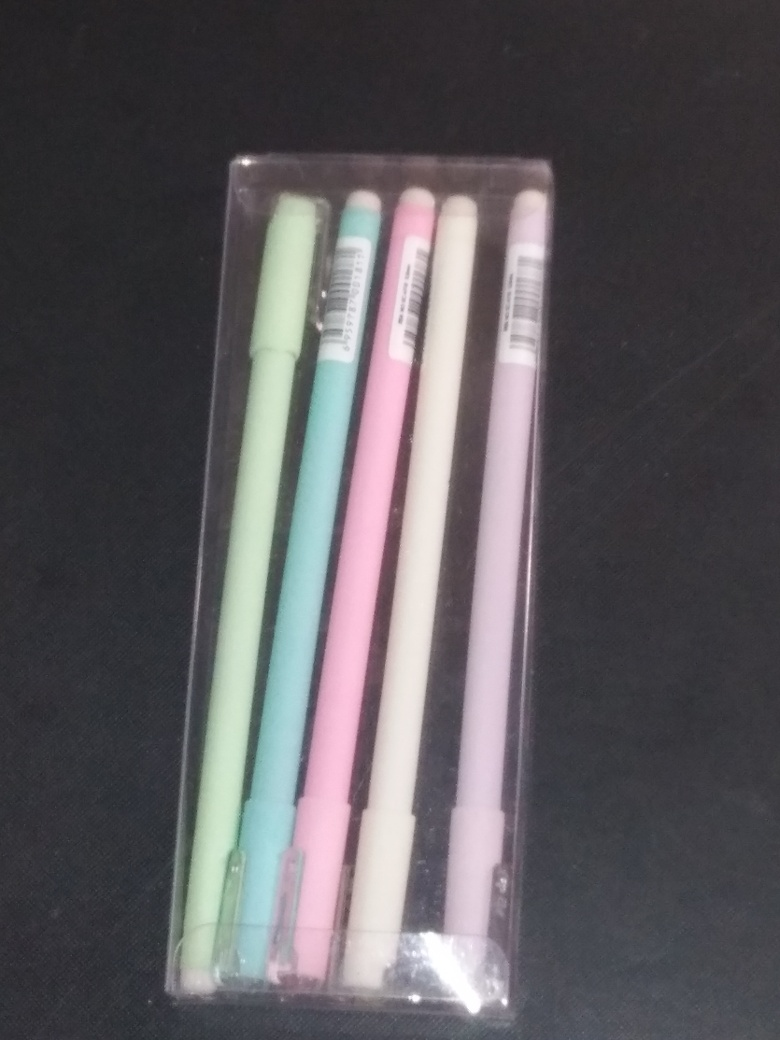How would you describe the quality of the image? The quality of the image could be improved; it appears slightly blurry and lacks sharpness, which suggests it's not of exceptional or excellent quality. However, it is clear enough to discern the main subjects of the photo: a set of pens in a transparent plastic case. 